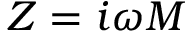<formula> <loc_0><loc_0><loc_500><loc_500>Z = i \omega M</formula> 